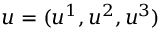<formula> <loc_0><loc_0><loc_500><loc_500>u = ( u ^ { 1 } , u ^ { 2 } , u ^ { 3 } )</formula> 